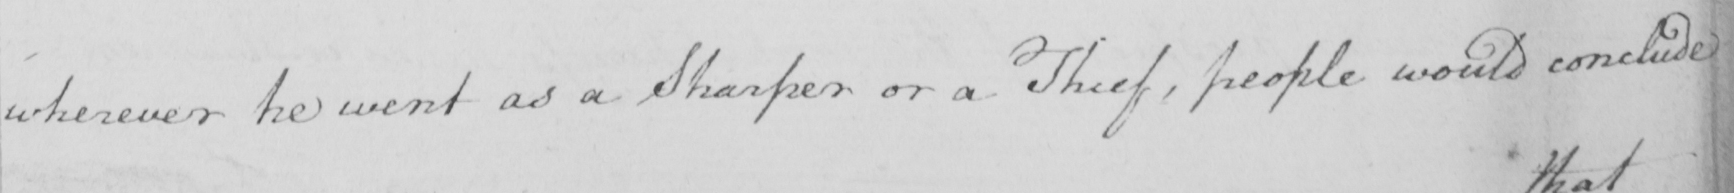What is written in this line of handwriting? wherever he went as a Sharper or a Thief , people would conclude 